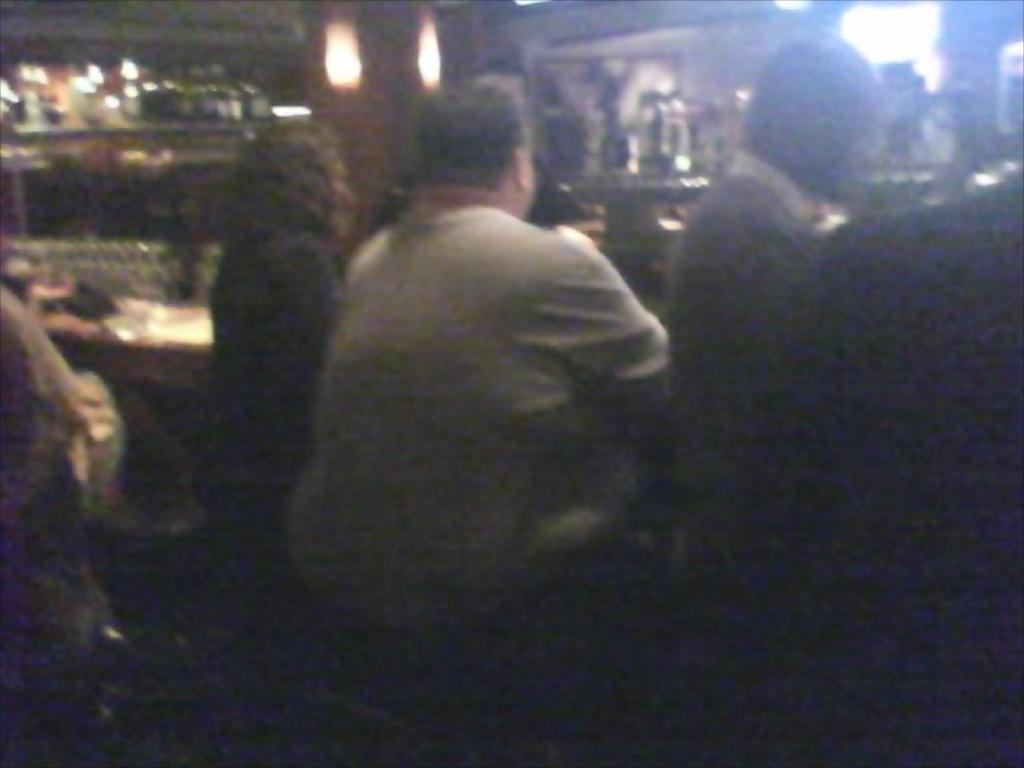What can be seen in the image? There are people and objects in the image. Can you describe the people in the image? Unfortunately, the provided facts do not give any specific details about the people in the image. What types of objects are present in the image? The provided facts do not give any specific details about the objects in the image. How many oranges are being used as decorations in the church in the image? There is no church or oranges present in the image, so it is not possible to answer that question. 